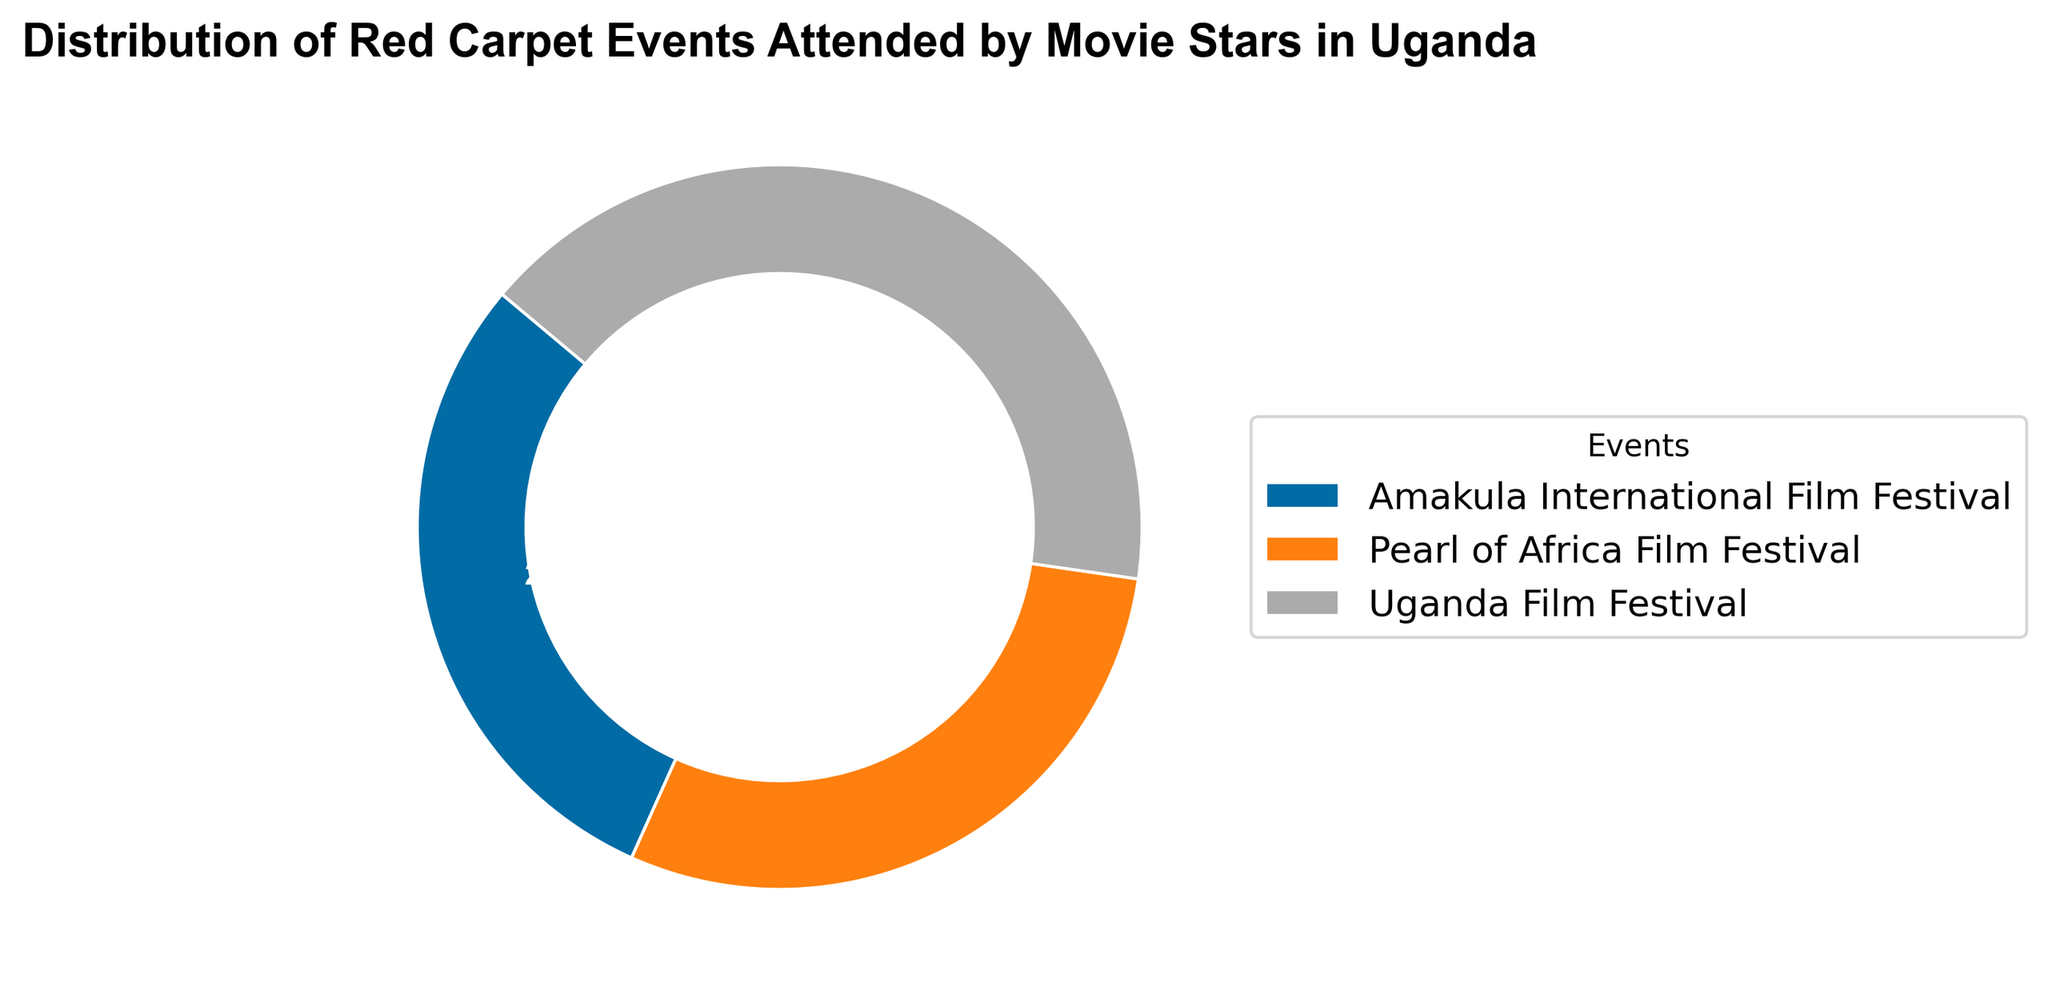what percentage of events were attended at the Uganda Film Festival? The Uganda Film Festival section in the ring chart shows 56.3%.
Answer: 56.3% which event had the second-highest attendance? The ring chart shows the Uganda Film Festival with the highest percentage at 56.3%, followed by the Pearl of Africa Film Festival at 37.5%. Thus, the Pearl of Africa Film Festival has the second-highest attendance.
Answer: Pearl of Africa Film Festival how much more attendance did Uganda Film Festival have compared to Amakula International Film Festival? Uganda Film Festival has 56.3% and Amakula International Film Festival has 18.8%. The difference is 56.3% - 18.8% = 37.5%.
Answer: 37.5% is the attendance for Pearl of Africa Film Festival greater than the combined attendance for Amakula International Film Festival and Uganda Film Festival? The Pearl of Africa Film Festival has 37.5%. The combined attendance for Uganda Film Festival (56.3%) and Amakula International Film Festival (18.8%) is 75.1%. Therefore, 37.5% is less than 75.1%.
Answer: No if the total attendance sums up to 320, how many attended the Amakula International Film Festival? Amakula International Film Festival represents 18.8% of the total attendance. 18.8% of 320 is equivalent to 0.188 * 320 = 60.16, approximately 60 people.
Answer: 60 how does the attendance at Pearl of Africa Film Festival compare to Uganda Film Festival in terms of ratio? Pearl of Africa Film Festival has 37.5% and Uganda Film Festival has 56.3%. The ratio is 37.5 to 56.3 or simplified, 37.5/56.3 = 0.67.
Answer: 0.67 what percentage of the total events does the Amakula International Film Festival represent? The Amakula International Film Festival section in the ring chart shows 18.8%.
Answer: 18.8% what is the combined attendance for Uganda Film Festival and Pearl of Africa Film Festival? Uganda Film Festival has 56.3% and Pearl of Africa Film Festival has 37.5%. Combined attendance is 56.3% + 37.5% = 93.8%.
Answer: 93.8% 